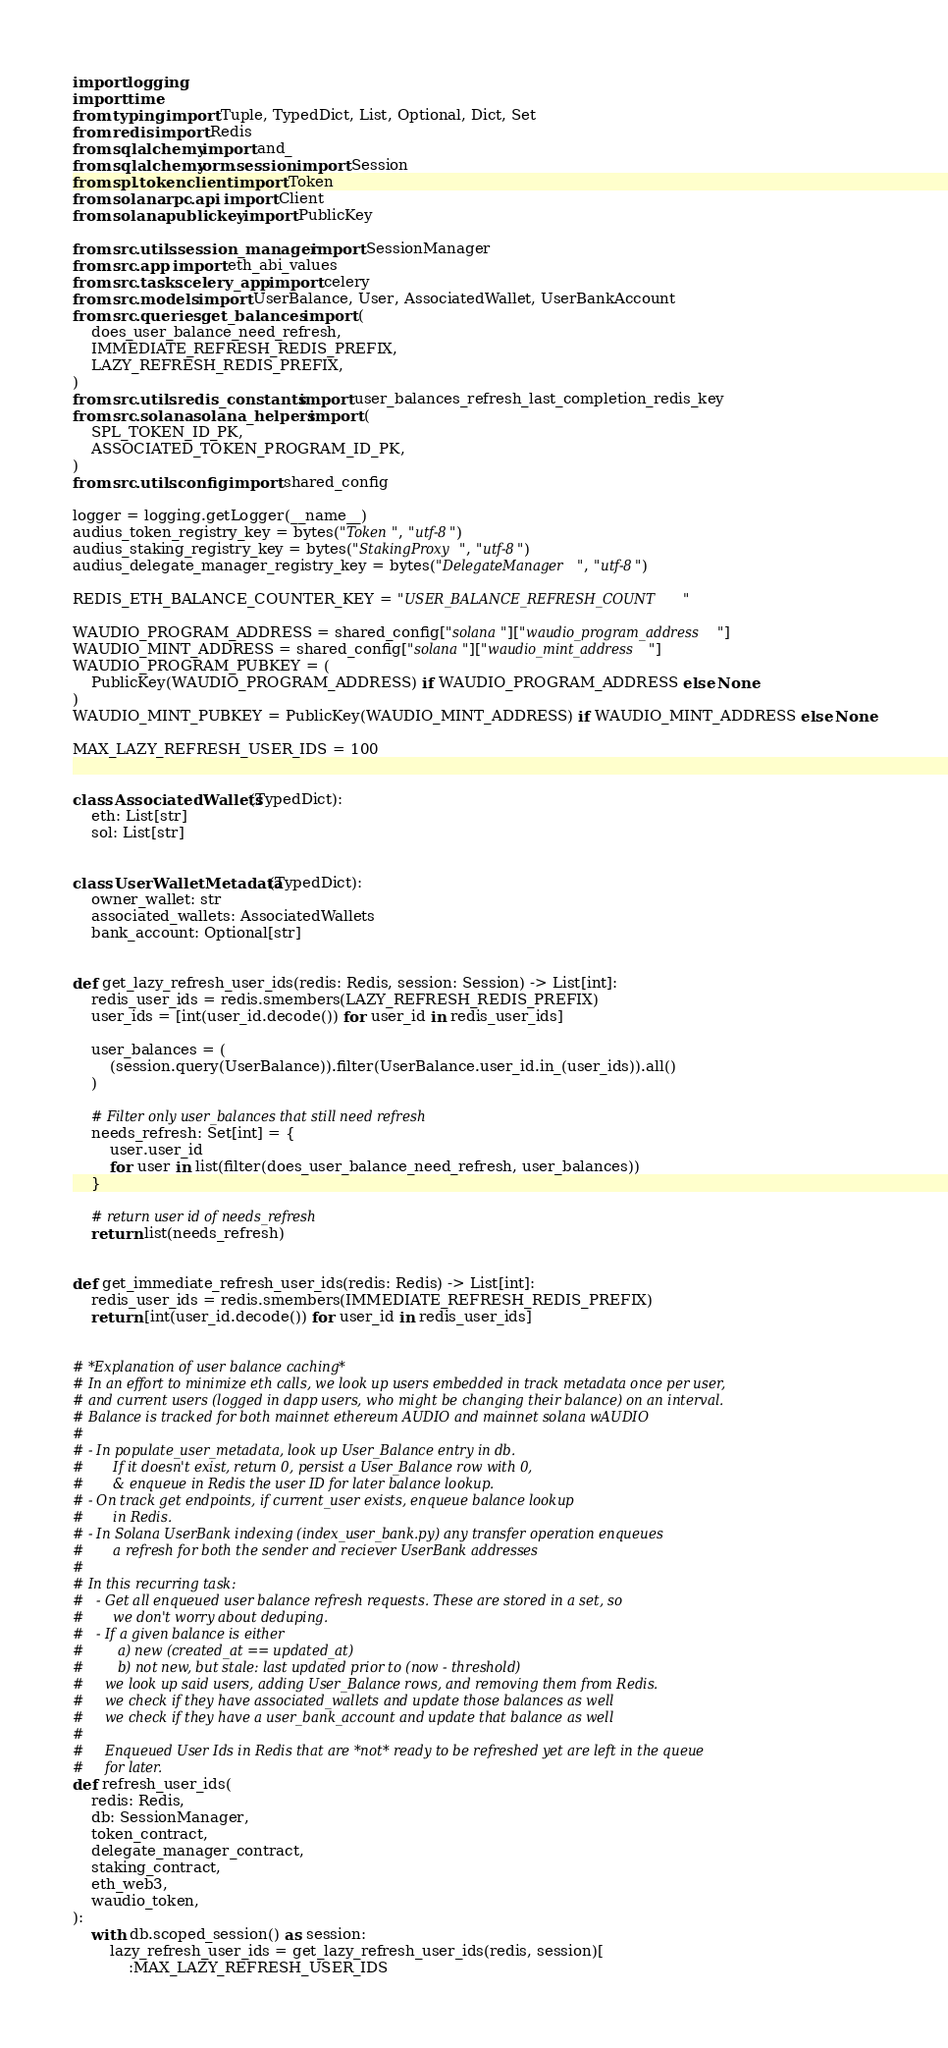Convert code to text. <code><loc_0><loc_0><loc_500><loc_500><_Python_>import logging
import time
from typing import Tuple, TypedDict, List, Optional, Dict, Set
from redis import Redis
from sqlalchemy import and_
from sqlalchemy.orm.session import Session
from spl.token.client import Token
from solana.rpc.api import Client
from solana.publickey import PublicKey

from src.utils.session_manager import SessionManager
from src.app import eth_abi_values
from src.tasks.celery_app import celery
from src.models import UserBalance, User, AssociatedWallet, UserBankAccount
from src.queries.get_balances import (
    does_user_balance_need_refresh,
    IMMEDIATE_REFRESH_REDIS_PREFIX,
    LAZY_REFRESH_REDIS_PREFIX,
)
from src.utils.redis_constants import user_balances_refresh_last_completion_redis_key
from src.solana.solana_helpers import (
    SPL_TOKEN_ID_PK,
    ASSOCIATED_TOKEN_PROGRAM_ID_PK,
)
from src.utils.config import shared_config

logger = logging.getLogger(__name__)
audius_token_registry_key = bytes("Token", "utf-8")
audius_staking_registry_key = bytes("StakingProxy", "utf-8")
audius_delegate_manager_registry_key = bytes("DelegateManager", "utf-8")

REDIS_ETH_BALANCE_COUNTER_KEY = "USER_BALANCE_REFRESH_COUNT"

WAUDIO_PROGRAM_ADDRESS = shared_config["solana"]["waudio_program_address"]
WAUDIO_MINT_ADDRESS = shared_config["solana"]["waudio_mint_address"]
WAUDIO_PROGRAM_PUBKEY = (
    PublicKey(WAUDIO_PROGRAM_ADDRESS) if WAUDIO_PROGRAM_ADDRESS else None
)
WAUDIO_MINT_PUBKEY = PublicKey(WAUDIO_MINT_ADDRESS) if WAUDIO_MINT_ADDRESS else None

MAX_LAZY_REFRESH_USER_IDS = 100


class AssociatedWallets(TypedDict):
    eth: List[str]
    sol: List[str]


class UserWalletMetadata(TypedDict):
    owner_wallet: str
    associated_wallets: AssociatedWallets
    bank_account: Optional[str]


def get_lazy_refresh_user_ids(redis: Redis, session: Session) -> List[int]:
    redis_user_ids = redis.smembers(LAZY_REFRESH_REDIS_PREFIX)
    user_ids = [int(user_id.decode()) for user_id in redis_user_ids]

    user_balances = (
        (session.query(UserBalance)).filter(UserBalance.user_id.in_(user_ids)).all()
    )

    # Filter only user_balances that still need refresh
    needs_refresh: Set[int] = {
        user.user_id
        for user in list(filter(does_user_balance_need_refresh, user_balances))
    }

    # return user id of needs_refresh
    return list(needs_refresh)


def get_immediate_refresh_user_ids(redis: Redis) -> List[int]:
    redis_user_ids = redis.smembers(IMMEDIATE_REFRESH_REDIS_PREFIX)
    return [int(user_id.decode()) for user_id in redis_user_ids]


# *Explanation of user balance caching*
# In an effort to minimize eth calls, we look up users embedded in track metadata once per user,
# and current users (logged in dapp users, who might be changing their balance) on an interval.
# Balance is tracked for both mainnet ethereum AUDIO and mainnet solana wAUDIO
#
# - In populate_user_metadata, look up User_Balance entry in db.
#       If it doesn't exist, return 0, persist a User_Balance row with 0,
#       & enqueue in Redis the user ID for later balance lookup.
# - On track get endpoints, if current_user exists, enqueue balance lookup
#       in Redis.
# - In Solana UserBank indexing (index_user_bank.py) any transfer operation enqueues
#       a refresh for both the sender and reciever UserBank addresses
#
# In this recurring task:
#   - Get all enqueued user balance refresh requests. These are stored in a set, so
#       we don't worry about deduping.
#   - If a given balance is either
#        a) new (created_at == updated_at)
#        b) not new, but stale: last updated prior to (now - threshold)
#     we look up said users, adding User_Balance rows, and removing them from Redis.
#     we check if they have associated_wallets and update those balances as well
#     we check if they have a user_bank_account and update that balance as well
#
#     Enqueued User Ids in Redis that are *not* ready to be refreshed yet are left in the queue
#     for later.
def refresh_user_ids(
    redis: Redis,
    db: SessionManager,
    token_contract,
    delegate_manager_contract,
    staking_contract,
    eth_web3,
    waudio_token,
):
    with db.scoped_session() as session:
        lazy_refresh_user_ids = get_lazy_refresh_user_ids(redis, session)[
            :MAX_LAZY_REFRESH_USER_IDS</code> 